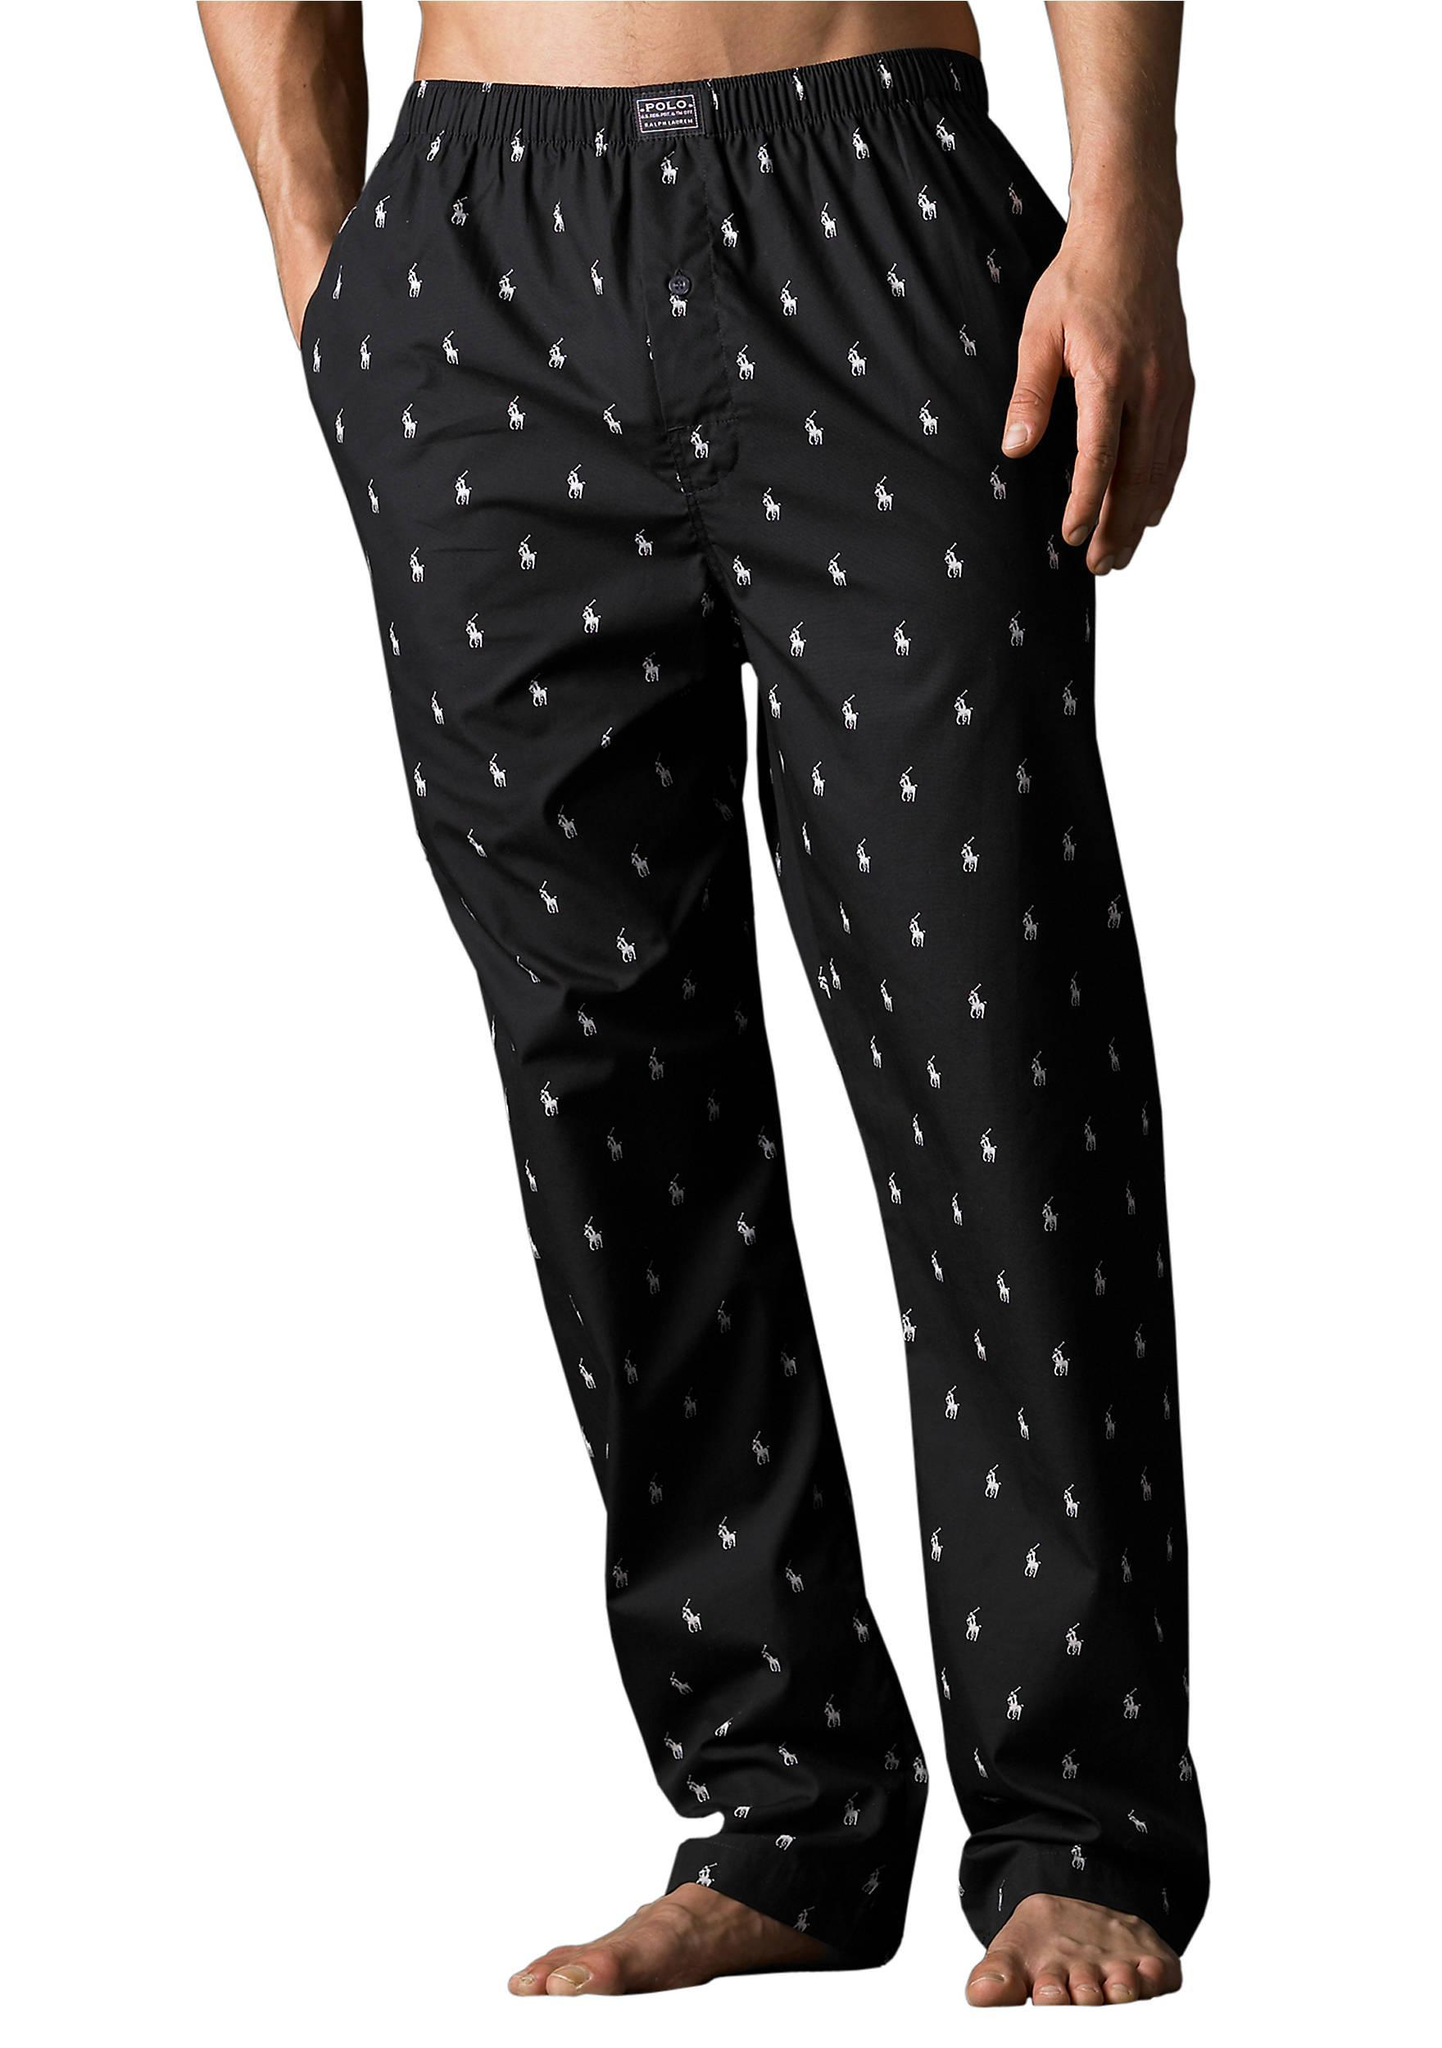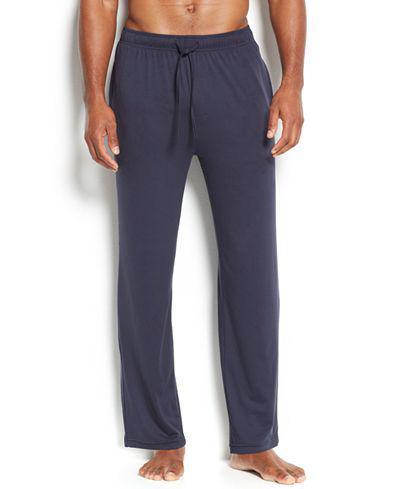The first image is the image on the left, the second image is the image on the right. Considering the images on both sides, is "The image on the left shows part of a woman's stomach." valid? Answer yes or no. No. 